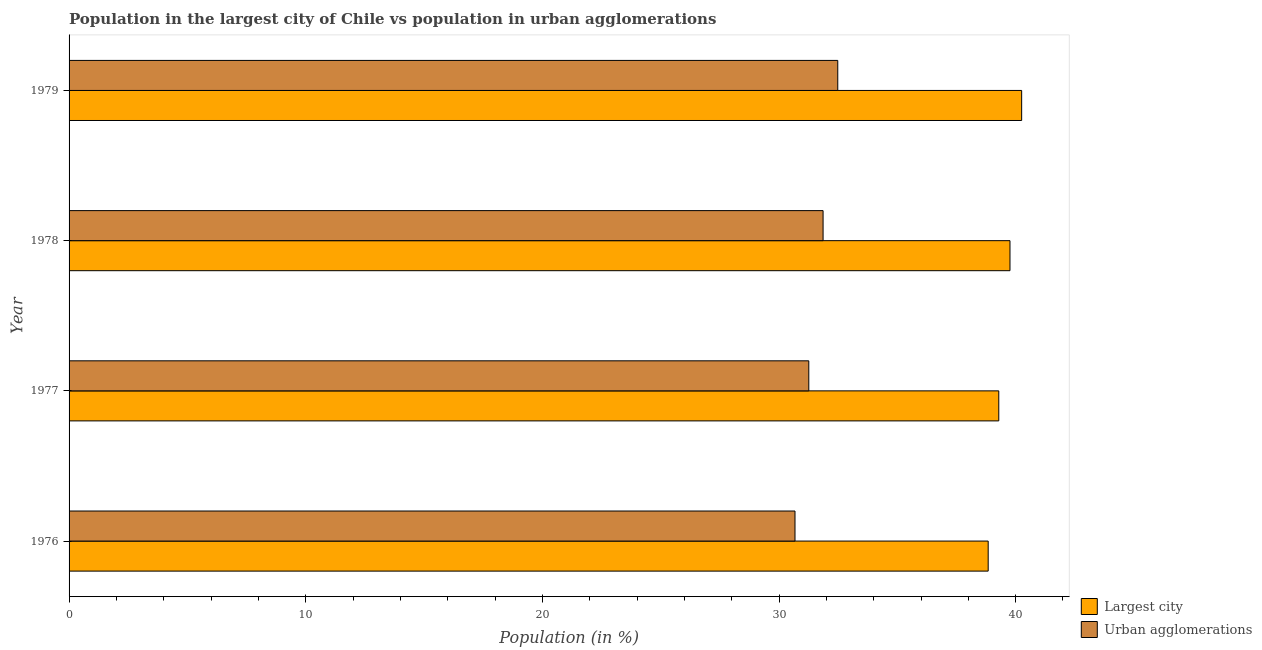How many groups of bars are there?
Offer a very short reply. 4. Are the number of bars on each tick of the Y-axis equal?
Make the answer very short. Yes. What is the label of the 3rd group of bars from the top?
Provide a short and direct response. 1977. What is the population in urban agglomerations in 1977?
Keep it short and to the point. 31.26. Across all years, what is the maximum population in urban agglomerations?
Your answer should be very brief. 32.48. Across all years, what is the minimum population in urban agglomerations?
Provide a succinct answer. 30.68. In which year was the population in the largest city maximum?
Offer a terse response. 1979. In which year was the population in urban agglomerations minimum?
Your answer should be compact. 1976. What is the total population in the largest city in the graph?
Provide a succinct answer. 158.14. What is the difference between the population in urban agglomerations in 1977 and that in 1978?
Keep it short and to the point. -0.6. What is the difference between the population in urban agglomerations in 1979 and the population in the largest city in 1978?
Provide a succinct answer. -7.28. What is the average population in urban agglomerations per year?
Offer a very short reply. 31.57. In the year 1979, what is the difference between the population in urban agglomerations and population in the largest city?
Give a very brief answer. -7.77. Is the population in the largest city in 1977 less than that in 1978?
Ensure brevity in your answer.  Yes. Is the difference between the population in urban agglomerations in 1976 and 1979 greater than the difference between the population in the largest city in 1976 and 1979?
Your answer should be compact. No. What is the difference between the highest and the second highest population in the largest city?
Offer a very short reply. 0.49. What is the difference between the highest and the lowest population in the largest city?
Make the answer very short. 1.41. In how many years, is the population in urban agglomerations greater than the average population in urban agglomerations taken over all years?
Keep it short and to the point. 2. What does the 2nd bar from the top in 1976 represents?
Provide a succinct answer. Largest city. What does the 1st bar from the bottom in 1977 represents?
Your answer should be compact. Largest city. What is the difference between two consecutive major ticks on the X-axis?
Your response must be concise. 10. Are the values on the major ticks of X-axis written in scientific E-notation?
Provide a succinct answer. No. Where does the legend appear in the graph?
Make the answer very short. Bottom right. How many legend labels are there?
Provide a short and direct response. 2. What is the title of the graph?
Your response must be concise. Population in the largest city of Chile vs population in urban agglomerations. What is the Population (in %) in Largest city in 1976?
Provide a succinct answer. 38.84. What is the Population (in %) in Urban agglomerations in 1976?
Offer a very short reply. 30.68. What is the Population (in %) of Largest city in 1977?
Your answer should be very brief. 39.29. What is the Population (in %) in Urban agglomerations in 1977?
Provide a short and direct response. 31.26. What is the Population (in %) in Largest city in 1978?
Your response must be concise. 39.76. What is the Population (in %) of Urban agglomerations in 1978?
Keep it short and to the point. 31.86. What is the Population (in %) of Largest city in 1979?
Your response must be concise. 40.25. What is the Population (in %) in Urban agglomerations in 1979?
Give a very brief answer. 32.48. Across all years, what is the maximum Population (in %) in Largest city?
Your response must be concise. 40.25. Across all years, what is the maximum Population (in %) of Urban agglomerations?
Your answer should be compact. 32.48. Across all years, what is the minimum Population (in %) in Largest city?
Provide a short and direct response. 38.84. Across all years, what is the minimum Population (in %) of Urban agglomerations?
Offer a very short reply. 30.68. What is the total Population (in %) in Largest city in the graph?
Offer a terse response. 158.14. What is the total Population (in %) in Urban agglomerations in the graph?
Give a very brief answer. 126.28. What is the difference between the Population (in %) in Largest city in 1976 and that in 1977?
Provide a succinct answer. -0.45. What is the difference between the Population (in %) of Urban agglomerations in 1976 and that in 1977?
Your response must be concise. -0.58. What is the difference between the Population (in %) of Largest city in 1976 and that in 1978?
Provide a short and direct response. -0.92. What is the difference between the Population (in %) in Urban agglomerations in 1976 and that in 1978?
Keep it short and to the point. -1.19. What is the difference between the Population (in %) in Largest city in 1976 and that in 1979?
Offer a very short reply. -1.41. What is the difference between the Population (in %) in Urban agglomerations in 1976 and that in 1979?
Make the answer very short. -1.81. What is the difference between the Population (in %) of Largest city in 1977 and that in 1978?
Provide a succinct answer. -0.47. What is the difference between the Population (in %) of Urban agglomerations in 1977 and that in 1978?
Offer a very short reply. -0.6. What is the difference between the Population (in %) of Largest city in 1977 and that in 1979?
Provide a succinct answer. -0.97. What is the difference between the Population (in %) in Urban agglomerations in 1977 and that in 1979?
Give a very brief answer. -1.22. What is the difference between the Population (in %) of Largest city in 1978 and that in 1979?
Keep it short and to the point. -0.49. What is the difference between the Population (in %) in Urban agglomerations in 1978 and that in 1979?
Your answer should be compact. -0.62. What is the difference between the Population (in %) in Largest city in 1976 and the Population (in %) in Urban agglomerations in 1977?
Your answer should be compact. 7.58. What is the difference between the Population (in %) in Largest city in 1976 and the Population (in %) in Urban agglomerations in 1978?
Provide a succinct answer. 6.98. What is the difference between the Population (in %) in Largest city in 1976 and the Population (in %) in Urban agglomerations in 1979?
Provide a succinct answer. 6.36. What is the difference between the Population (in %) in Largest city in 1977 and the Population (in %) in Urban agglomerations in 1978?
Provide a short and direct response. 7.42. What is the difference between the Population (in %) of Largest city in 1977 and the Population (in %) of Urban agglomerations in 1979?
Provide a short and direct response. 6.8. What is the difference between the Population (in %) in Largest city in 1978 and the Population (in %) in Urban agglomerations in 1979?
Your answer should be compact. 7.28. What is the average Population (in %) in Largest city per year?
Your answer should be very brief. 39.53. What is the average Population (in %) of Urban agglomerations per year?
Offer a terse response. 31.57. In the year 1976, what is the difference between the Population (in %) in Largest city and Population (in %) in Urban agglomerations?
Your answer should be very brief. 8.16. In the year 1977, what is the difference between the Population (in %) of Largest city and Population (in %) of Urban agglomerations?
Provide a succinct answer. 8.03. In the year 1978, what is the difference between the Population (in %) of Largest city and Population (in %) of Urban agglomerations?
Provide a short and direct response. 7.9. In the year 1979, what is the difference between the Population (in %) of Largest city and Population (in %) of Urban agglomerations?
Your answer should be compact. 7.77. What is the ratio of the Population (in %) in Urban agglomerations in 1976 to that in 1977?
Provide a short and direct response. 0.98. What is the ratio of the Population (in %) of Largest city in 1976 to that in 1978?
Offer a very short reply. 0.98. What is the ratio of the Population (in %) of Urban agglomerations in 1976 to that in 1978?
Keep it short and to the point. 0.96. What is the ratio of the Population (in %) in Largest city in 1976 to that in 1979?
Offer a very short reply. 0.96. What is the ratio of the Population (in %) of Urban agglomerations in 1976 to that in 1979?
Your response must be concise. 0.94. What is the ratio of the Population (in %) in Urban agglomerations in 1977 to that in 1979?
Offer a terse response. 0.96. What is the ratio of the Population (in %) in Largest city in 1978 to that in 1979?
Provide a short and direct response. 0.99. What is the ratio of the Population (in %) in Urban agglomerations in 1978 to that in 1979?
Keep it short and to the point. 0.98. What is the difference between the highest and the second highest Population (in %) of Largest city?
Provide a succinct answer. 0.49. What is the difference between the highest and the second highest Population (in %) of Urban agglomerations?
Your answer should be very brief. 0.62. What is the difference between the highest and the lowest Population (in %) of Largest city?
Give a very brief answer. 1.41. What is the difference between the highest and the lowest Population (in %) in Urban agglomerations?
Make the answer very short. 1.81. 